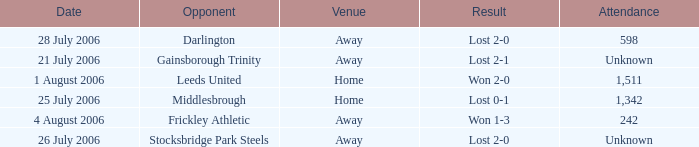What is the attendance rate for the Middlesbrough opponent? 1342.0. 